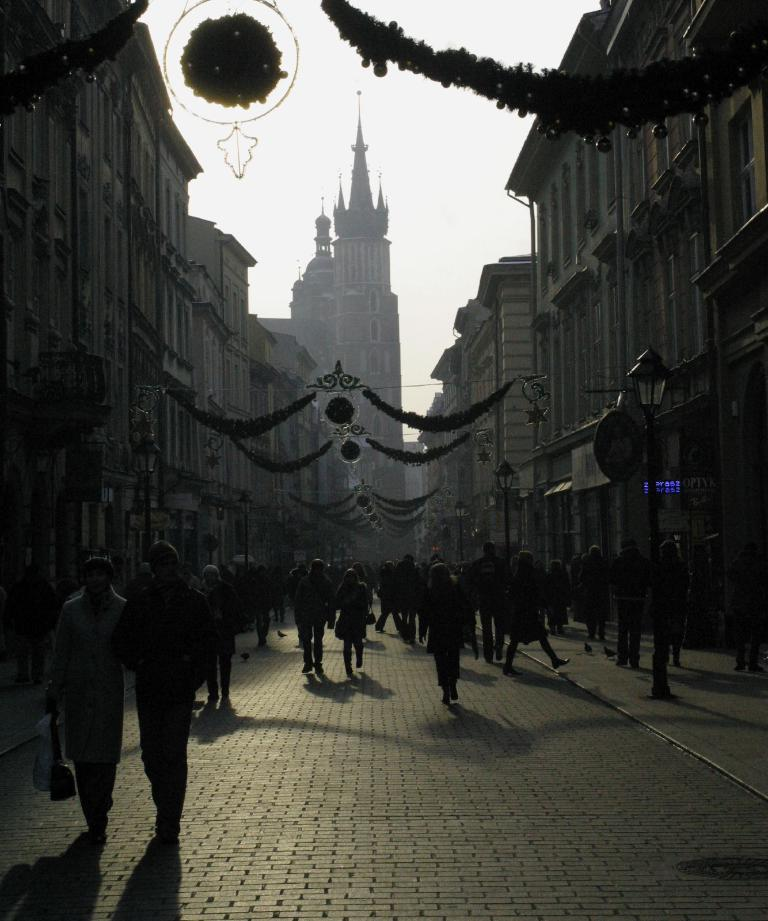What are the people in the image doing? The people in the image are walking on the road. What structures can be seen in the image? There are light poles, boards, and buildings visible in the image. What type of decorative items are present in the image? There are decorative items in the image, but their specific nature is not mentioned in the facts. What is visible in the background of the image? The sky is visible in the background of the image. How many cubs are sitting on the yoke in the image? There are no cubs or yokes present in the image. 